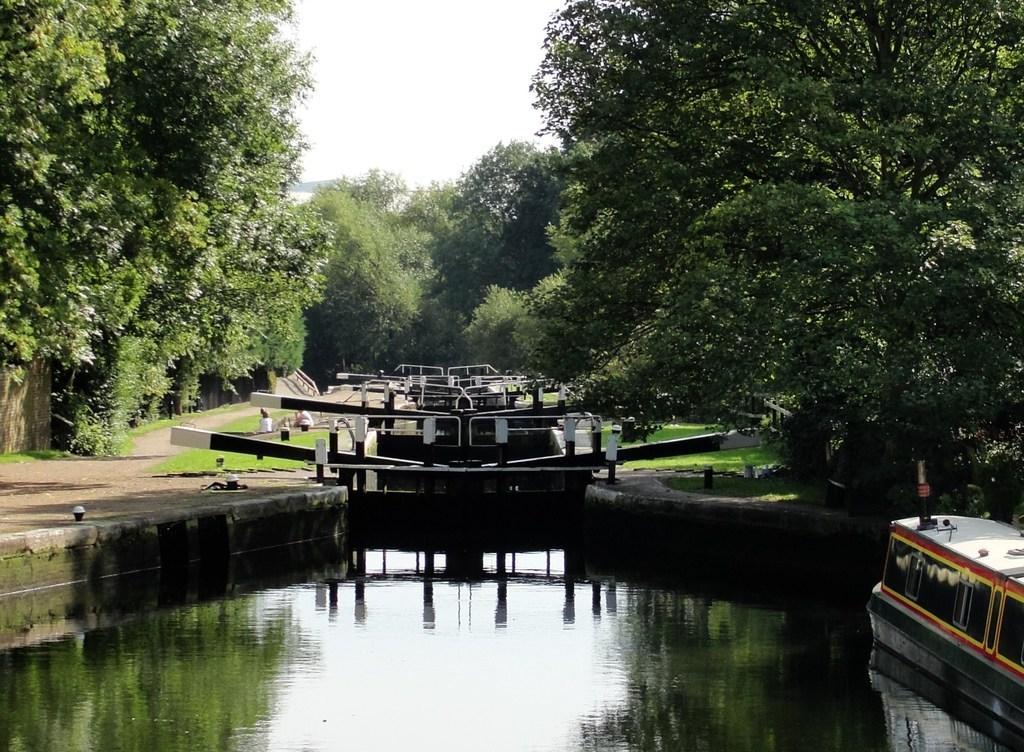How would you summarize this image in a sentence or two? In this image I can see there is a small lake, a boat at right side and there is an iron frame in the backdrop, there are few trees and the sky is clear. 